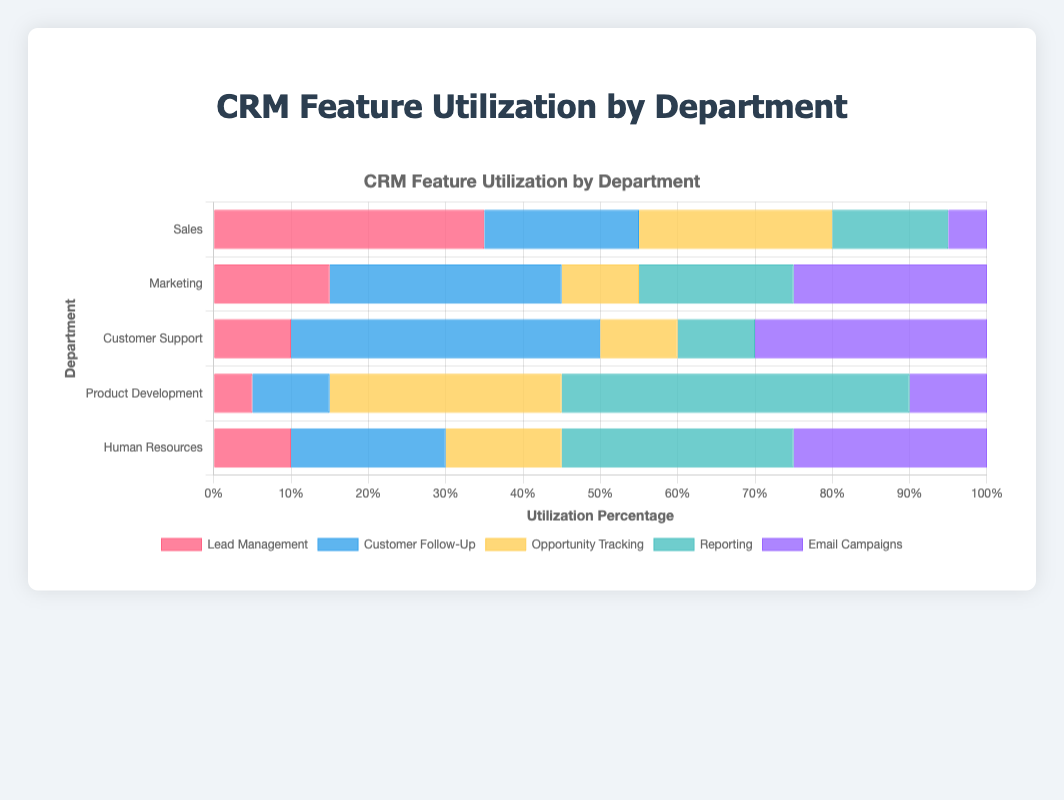What's the total utilization percentage for the Sales department? Sum the percentages for each CRM feature in the Sales department: 35 (Lead Management) + 20 (Customer Follow-Up) + 25 (Opportunity Tracking) + 15 (Reporting) + 5 (Email Campaigns) = 100%
Answer: 100% Which department has the highest utilization percentage for the Email Campaigns feature? Compare the values for Email Campaigns utilization across all departments. The values are Sales: 5%, Marketing: 25%, Customer Support: 30%, Product Development: 10%, Human Resources: 25%. Customer Support has the highest value of 30%
Answer: Customer Support In which department does Lead Management have the lowest utilization percentage? Compare the values for Lead Management utilization across all departments. The values are Sales: 35%, Marketing: 15%, Customer Support: 10%, Product Development: 5%, Human Resources: 10%. Product Development has the lowest value of 5%
Answer: Product Development What is the combined utilization percentage of Reporting and Email Campaigns for the Marketing department? Sum the percentages for Reporting and Email Campaigns in the Marketing department: 20 (Reporting) + 25 (Email Campaigns) = 45%
Answer: 45% Which CRM feature is utilized the most by the Product Development department? Compare the values for each feature in the Product Development department. The values are Lead Management: 5%, Customer Follow-Up: 10%, Opportunity Tracking: 30%, Reporting: 45%, Email Campaigns: 10%. Reporting has the highest value of 45%
Answer: Reporting Is the utilization percentage of Customer Follow-Up in Customer Support higher than in Human Resources? Compare the Customer Follow-Up values for Customer Support and Human Resources. Customer Support has 40%, and Human Resources has 20%. 40% is greater than 20%
Answer: Yes What is the difference in utilization percentage for Opportunity Tracking between Sales and Marketing? Subtract the Marketing utilization percentage from the Sales utilization percentage for Opportunity Tracking: 25 (Sales) - 10 (Marketing) = 15%
Answer: 15% Which department has the most balanced utilization across different CRM features? Analyze the spread of utilization percentages for each department to see if one department's values are more uniform (less variance) compared to others. The values for Human Resources are Lead Management: 10%, Customer Follow-Up: 20%, Opportunity Tracking: 15%, Reporting: 30%, Email Campaigns: 25%. These values have a relatively balanced distribution compared to other departments
Answer: Human Resources In which department is the utilization percentage for Reporting exactly 30%? Check the Reporting values for each department. Only the Human Resources department has a Reporting value of 30%
Answer: Human Resources What is the utilization percentage difference for Customer Follow-Up between Customer Support and the average value of all departments? Calculate the average Customer Follow-Up utilization across all departments: (20 + 30 + 40 + 10 + 20)/5 = 24%. Then, subtract this average from the Customer Follow-Up utilization in Customer Support: 40 - 24 = 16%
Answer: 16% 